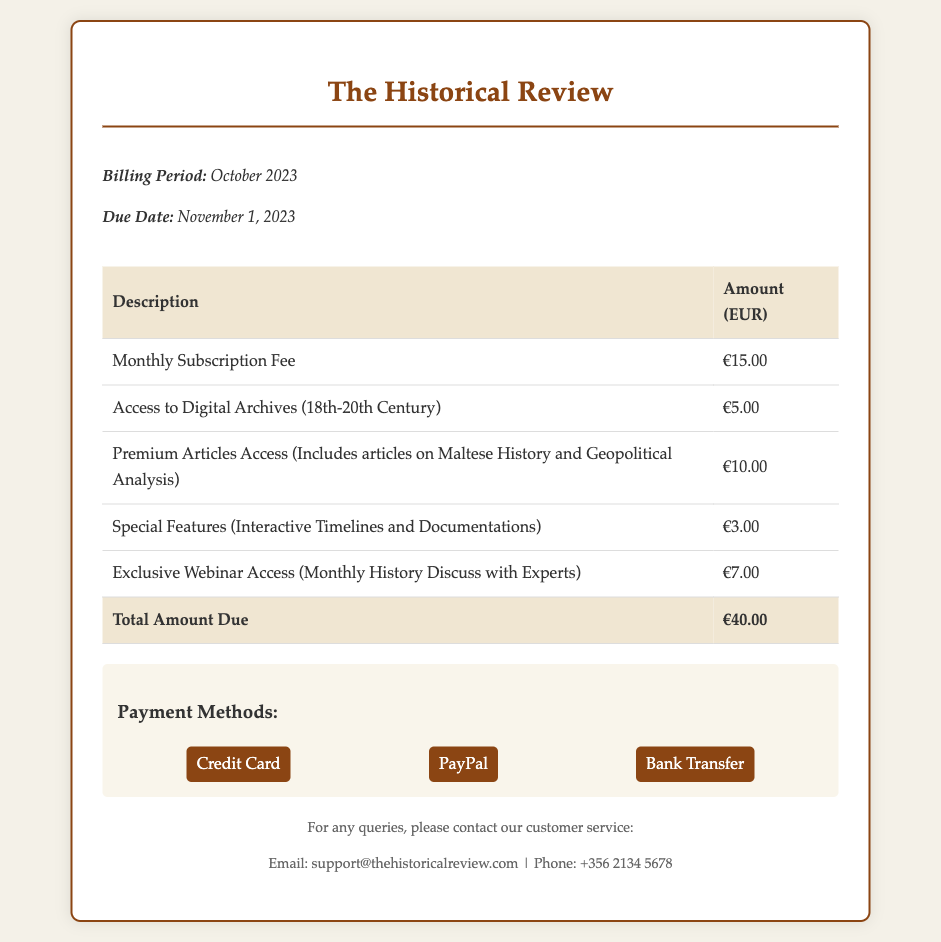What is the billing period? The billing period is explicitly mentioned in the document as October 2023.
Answer: October 2023 What is the total amount due? The document lists the total amount due after adding different charges in the table.
Answer: €40.00 What is the cost for access to digital archives? The document includes specific charges for various services, one of which is access to digital archives.
Answer: €5.00 When is the due date for the payment? The due date is indicated clearly in the document and is a specific date.
Answer: November 1, 2023 How much does exclusive webinar access cost? The cost for exclusive webinar access is clearly stated in the billing breakdown.
Answer: €7.00 Which method is NOT listed as a payment option? The document provides a list of payment methods, and identifying one that is not mentioned requires examination.
Answer: None (All listed) How many premium articles access costs? The document specifies the charge for premium articles access separately.
Answer: €10.00 What special features are included in the bill? The bill outlines the inclusive services, including special features, clearly in the table.
Answer: Interactive Timelines and Documentations What is the monthly subscription fee? The document states the amount for the monthly subscription fee very clearly.
Answer: €15.00 